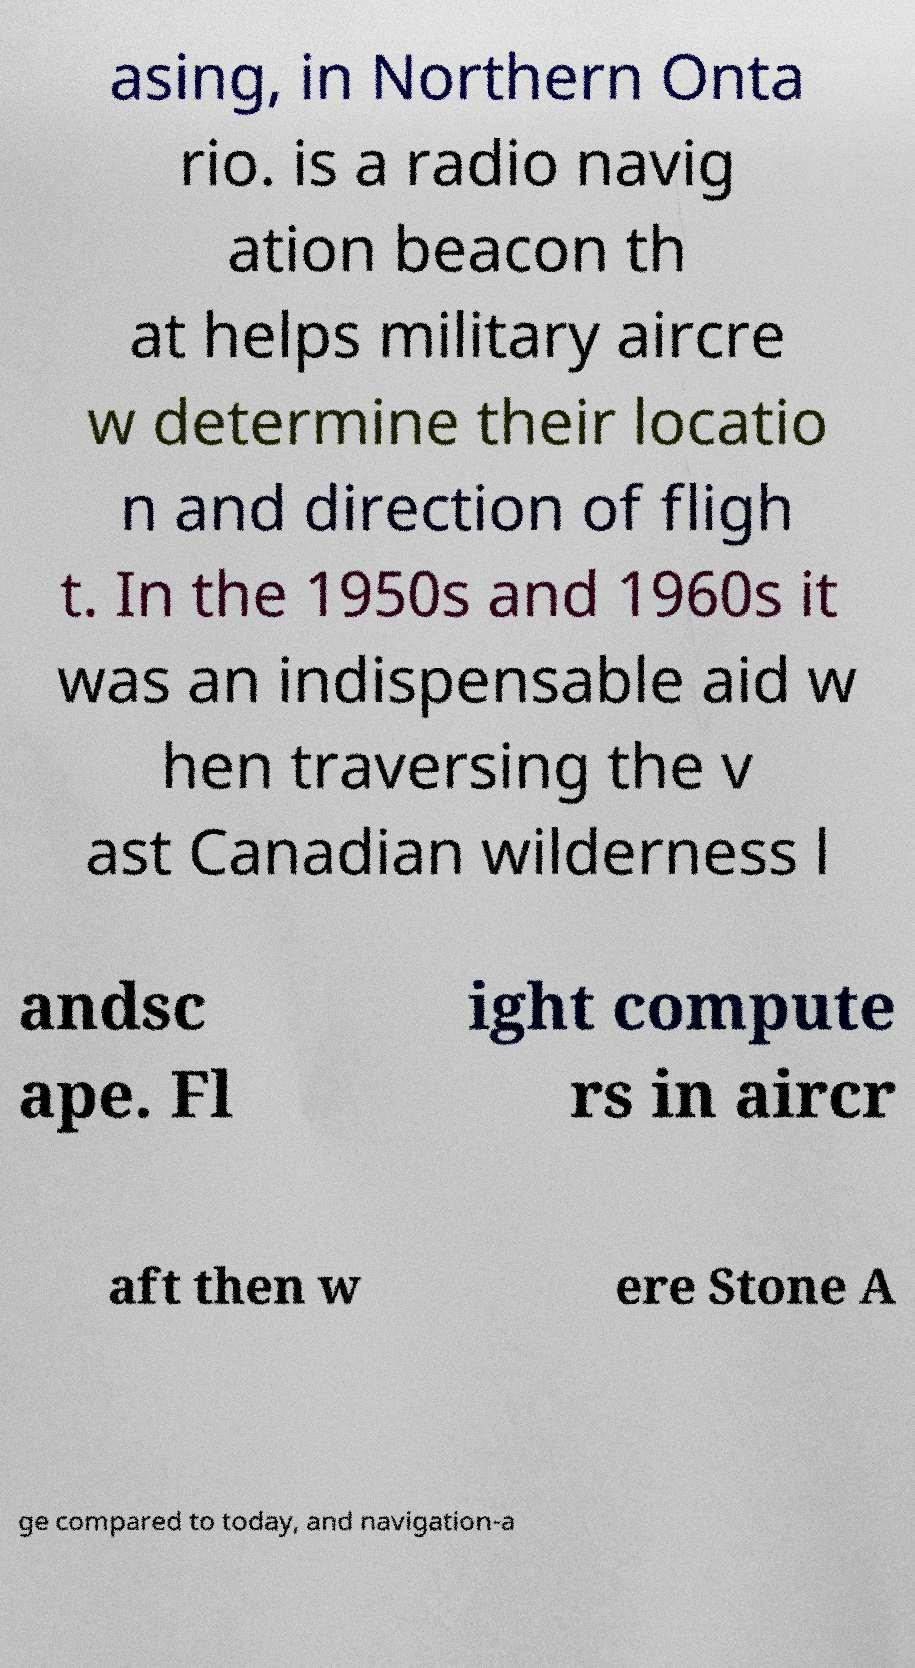Could you assist in decoding the text presented in this image and type it out clearly? asing, in Northern Onta rio. is a radio navig ation beacon th at helps military aircre w determine their locatio n and direction of fligh t. In the 1950s and 1960s it was an indispensable aid w hen traversing the v ast Canadian wilderness l andsc ape. Fl ight compute rs in aircr aft then w ere Stone A ge compared to today, and navigation-a 